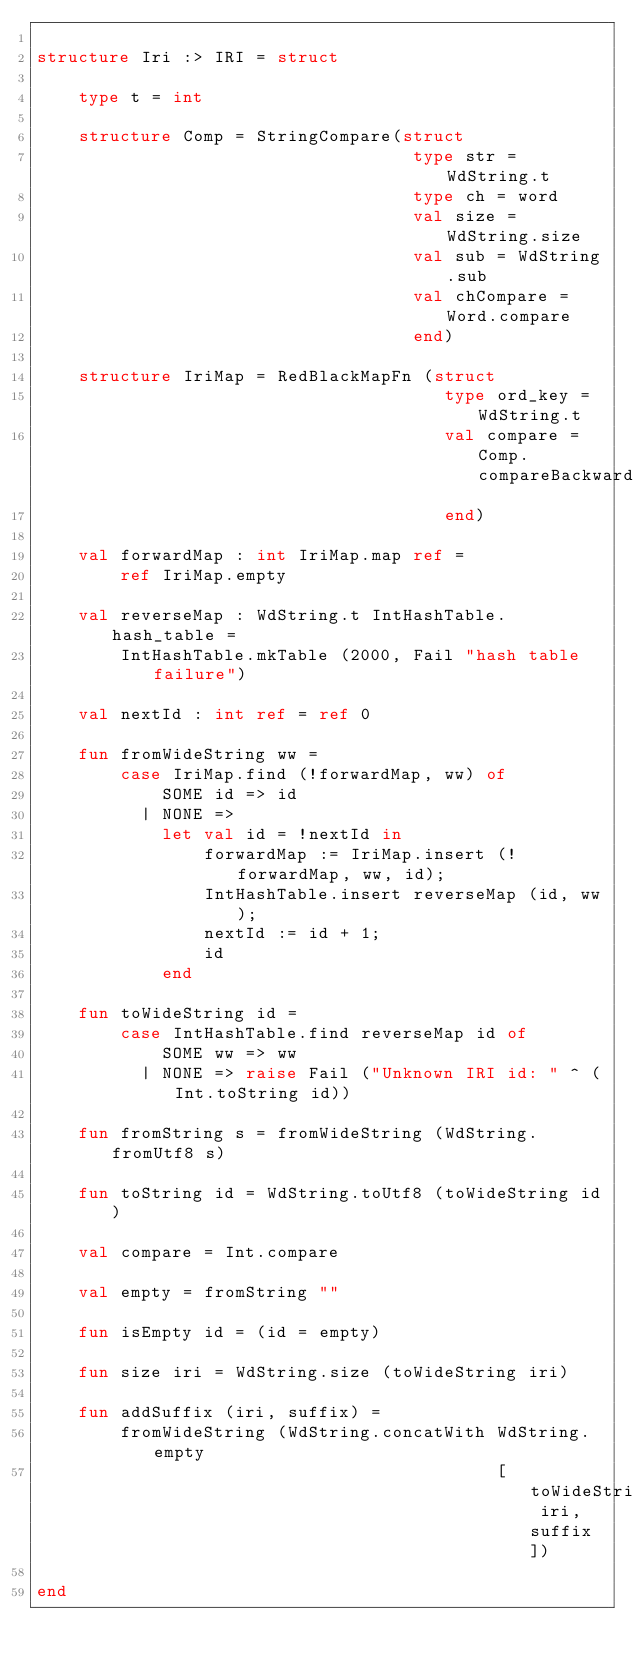Convert code to text. <code><loc_0><loc_0><loc_500><loc_500><_SML_>
structure Iri :> IRI = struct

    type t = int

    structure Comp = StringCompare(struct
                                    type str = WdString.t
                                    type ch = word
                                    val size = WdString.size
                                    val sub = WdString.sub
                                    val chCompare = Word.compare
                                    end)
                 
    structure IriMap = RedBlackMapFn (struct
                                       type ord_key = WdString.t
                                       val compare = Comp.compareBackwards
                                       end)

    val forwardMap : int IriMap.map ref =
        ref IriMap.empty
	
    val reverseMap : WdString.t IntHashTable.hash_table =
        IntHashTable.mkTable (2000, Fail "hash table failure")

    val nextId : int ref = ref 0

    fun fromWideString ww =
        case IriMap.find (!forwardMap, ww) of
            SOME id => id
          | NONE =>
            let val id = !nextId in
                forwardMap := IriMap.insert (!forwardMap, ww, id);
                IntHashTable.insert reverseMap (id, ww);
                nextId := id + 1;
                id
            end

    fun toWideString id =
        case IntHashTable.find reverseMap id of
            SOME ww => ww
          | NONE => raise Fail ("Unknown IRI id: " ^ (Int.toString id))

    fun fromString s = fromWideString (WdString.fromUtf8 s)

    fun toString id = WdString.toUtf8 (toWideString id)

    val compare = Int.compare

    val empty = fromString ""

    fun isEmpty id = (id = empty)

    fun size iri = WdString.size (toWideString iri)
			 
    fun addSuffix (iri, suffix) =
        fromWideString (WdString.concatWith WdString.empty
                                            [toWideString iri, suffix])
                         
end

                           
</code> 